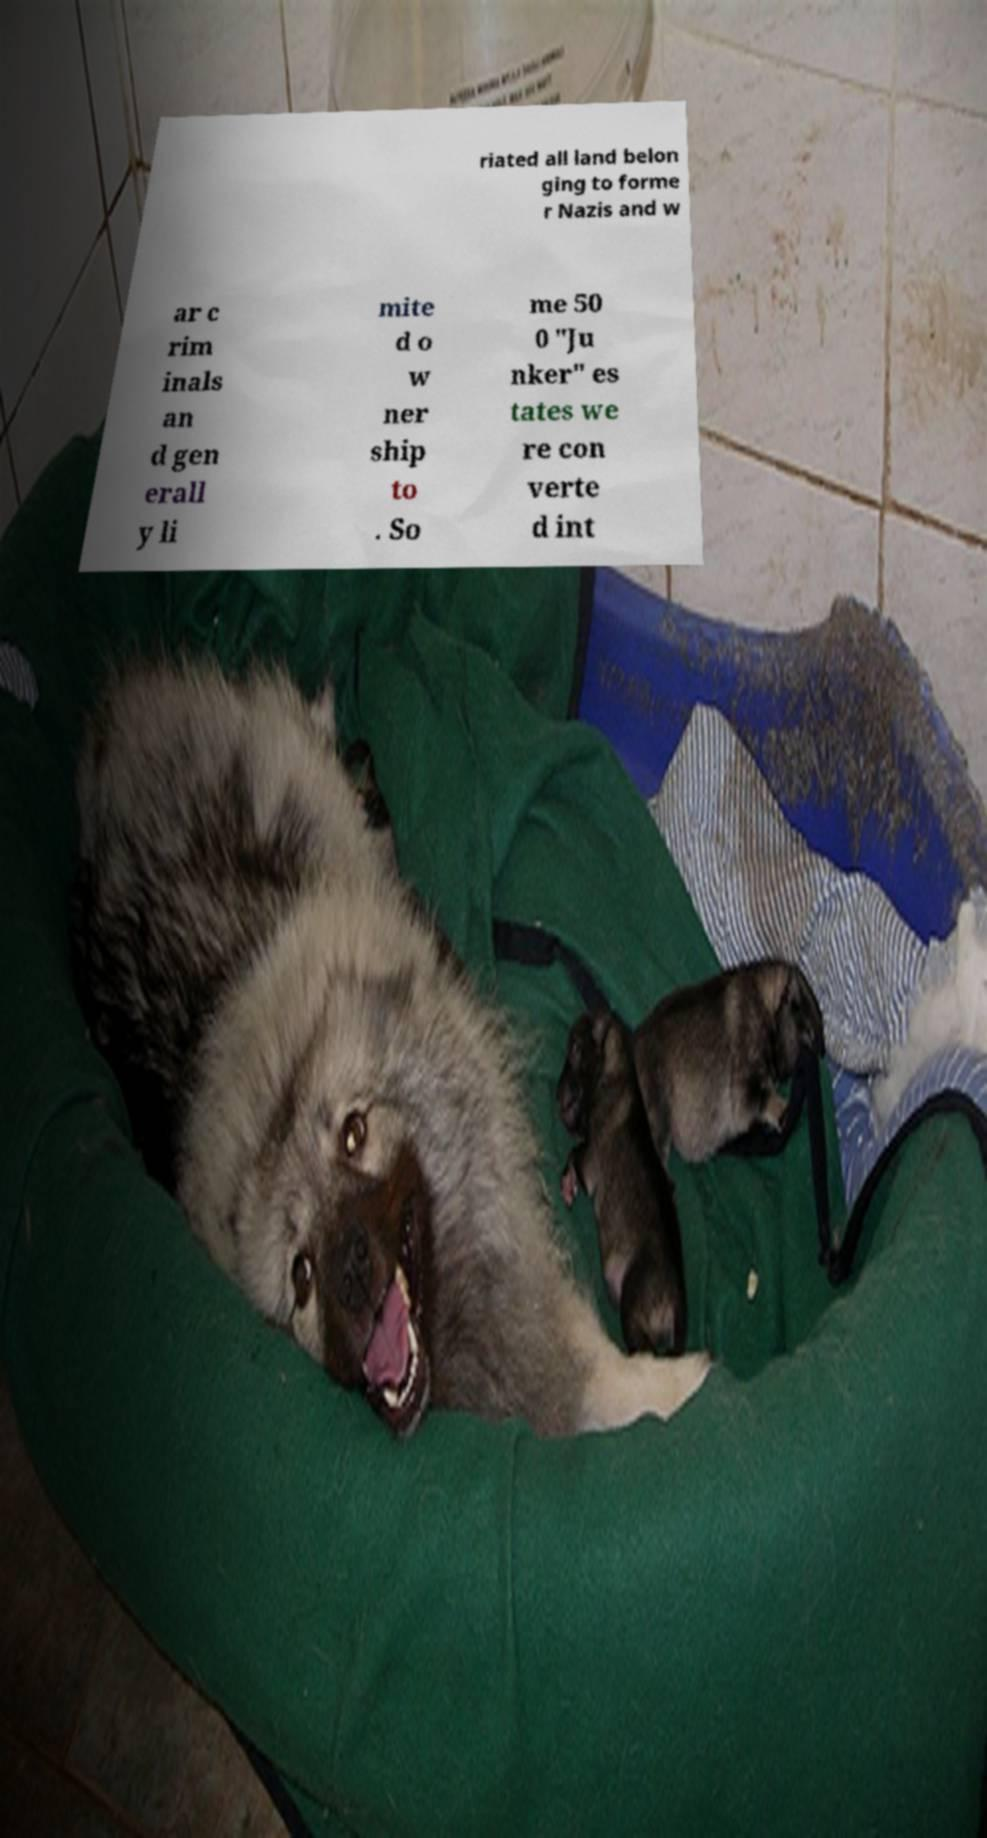There's text embedded in this image that I need extracted. Can you transcribe it verbatim? riated all land belon ging to forme r Nazis and w ar c rim inals an d gen erall y li mite d o w ner ship to . So me 50 0 "Ju nker" es tates we re con verte d int 